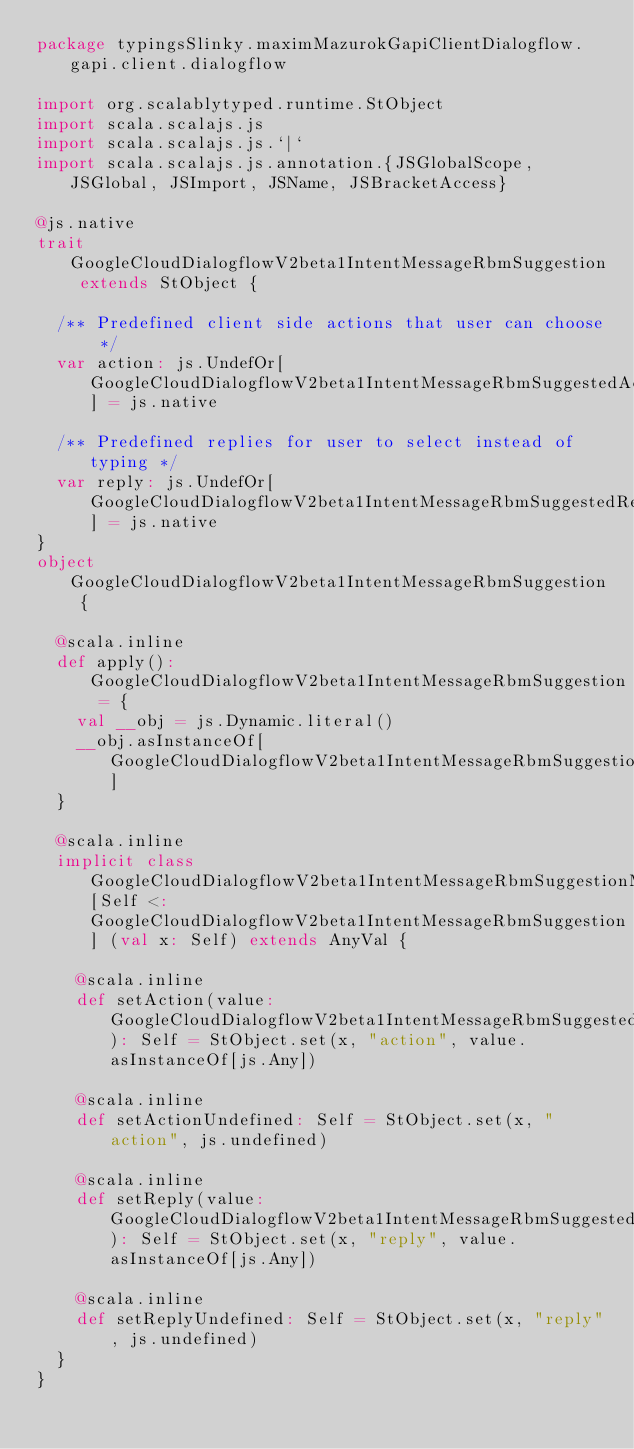<code> <loc_0><loc_0><loc_500><loc_500><_Scala_>package typingsSlinky.maximMazurokGapiClientDialogflow.gapi.client.dialogflow

import org.scalablytyped.runtime.StObject
import scala.scalajs.js
import scala.scalajs.js.`|`
import scala.scalajs.js.annotation.{JSGlobalScope, JSGlobal, JSImport, JSName, JSBracketAccess}

@js.native
trait GoogleCloudDialogflowV2beta1IntentMessageRbmSuggestion extends StObject {
  
  /** Predefined client side actions that user can choose */
  var action: js.UndefOr[GoogleCloudDialogflowV2beta1IntentMessageRbmSuggestedAction] = js.native
  
  /** Predefined replies for user to select instead of typing */
  var reply: js.UndefOr[GoogleCloudDialogflowV2beta1IntentMessageRbmSuggestedReply] = js.native
}
object GoogleCloudDialogflowV2beta1IntentMessageRbmSuggestion {
  
  @scala.inline
  def apply(): GoogleCloudDialogflowV2beta1IntentMessageRbmSuggestion = {
    val __obj = js.Dynamic.literal()
    __obj.asInstanceOf[GoogleCloudDialogflowV2beta1IntentMessageRbmSuggestion]
  }
  
  @scala.inline
  implicit class GoogleCloudDialogflowV2beta1IntentMessageRbmSuggestionMutableBuilder[Self <: GoogleCloudDialogflowV2beta1IntentMessageRbmSuggestion] (val x: Self) extends AnyVal {
    
    @scala.inline
    def setAction(value: GoogleCloudDialogflowV2beta1IntentMessageRbmSuggestedAction): Self = StObject.set(x, "action", value.asInstanceOf[js.Any])
    
    @scala.inline
    def setActionUndefined: Self = StObject.set(x, "action", js.undefined)
    
    @scala.inline
    def setReply(value: GoogleCloudDialogflowV2beta1IntentMessageRbmSuggestedReply): Self = StObject.set(x, "reply", value.asInstanceOf[js.Any])
    
    @scala.inline
    def setReplyUndefined: Self = StObject.set(x, "reply", js.undefined)
  }
}
</code> 